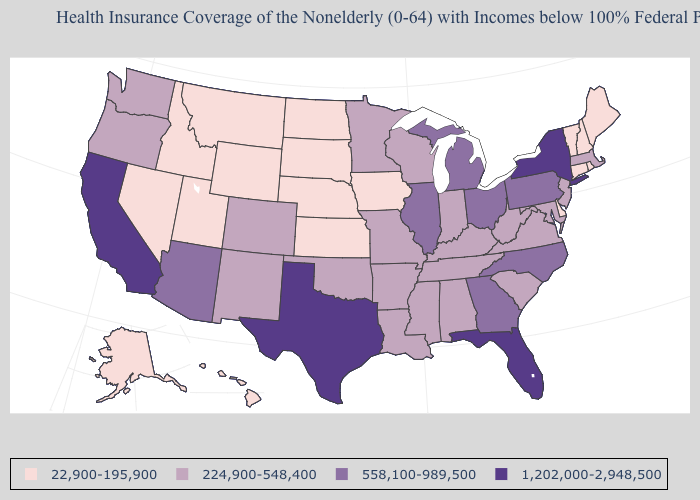What is the highest value in states that border North Carolina?
Be succinct. 558,100-989,500. Which states hav the highest value in the West?
Keep it brief. California. Which states have the lowest value in the MidWest?
Keep it brief. Iowa, Kansas, Nebraska, North Dakota, South Dakota. Name the states that have a value in the range 558,100-989,500?
Short answer required. Arizona, Georgia, Illinois, Michigan, North Carolina, Ohio, Pennsylvania. How many symbols are there in the legend?
Be succinct. 4. Does Maine have the lowest value in the Northeast?
Be succinct. Yes. Does the first symbol in the legend represent the smallest category?
Be succinct. Yes. Does the first symbol in the legend represent the smallest category?
Give a very brief answer. Yes. Does the map have missing data?
Be succinct. No. What is the value of Maryland?
Write a very short answer. 224,900-548,400. What is the highest value in the Northeast ?
Write a very short answer. 1,202,000-2,948,500. Does the map have missing data?
Short answer required. No. What is the value of Arkansas?
Give a very brief answer. 224,900-548,400. Name the states that have a value in the range 224,900-548,400?
Be succinct. Alabama, Arkansas, Colorado, Indiana, Kentucky, Louisiana, Maryland, Massachusetts, Minnesota, Mississippi, Missouri, New Jersey, New Mexico, Oklahoma, Oregon, South Carolina, Tennessee, Virginia, Washington, West Virginia, Wisconsin. 